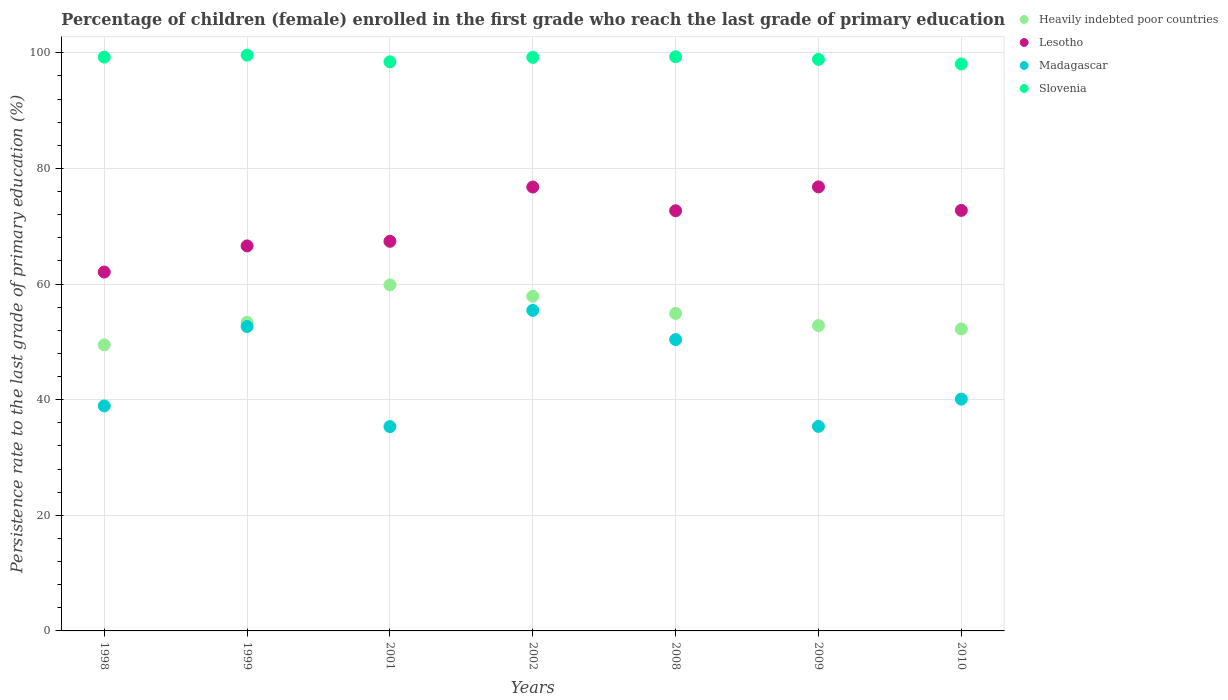How many different coloured dotlines are there?
Your answer should be compact. 4. What is the persistence rate of children in Lesotho in 1999?
Offer a terse response. 66.6. Across all years, what is the maximum persistence rate of children in Heavily indebted poor countries?
Make the answer very short. 59.87. Across all years, what is the minimum persistence rate of children in Lesotho?
Your answer should be compact. 62.08. What is the total persistence rate of children in Madagascar in the graph?
Your answer should be compact. 308.26. What is the difference between the persistence rate of children in Heavily indebted poor countries in 2002 and that in 2010?
Provide a short and direct response. 5.65. What is the difference between the persistence rate of children in Slovenia in 2001 and the persistence rate of children in Heavily indebted poor countries in 2008?
Keep it short and to the point. 43.53. What is the average persistence rate of children in Madagascar per year?
Offer a very short reply. 44.04. In the year 2010, what is the difference between the persistence rate of children in Madagascar and persistence rate of children in Heavily indebted poor countries?
Offer a terse response. -12.14. In how many years, is the persistence rate of children in Madagascar greater than 12 %?
Your answer should be compact. 7. What is the ratio of the persistence rate of children in Lesotho in 1999 to that in 2010?
Make the answer very short. 0.92. Is the persistence rate of children in Madagascar in 1999 less than that in 2010?
Offer a very short reply. No. Is the difference between the persistence rate of children in Madagascar in 1999 and 2010 greater than the difference between the persistence rate of children in Heavily indebted poor countries in 1999 and 2010?
Offer a terse response. Yes. What is the difference between the highest and the second highest persistence rate of children in Slovenia?
Provide a succinct answer. 0.28. What is the difference between the highest and the lowest persistence rate of children in Heavily indebted poor countries?
Provide a succinct answer. 10.38. In how many years, is the persistence rate of children in Heavily indebted poor countries greater than the average persistence rate of children in Heavily indebted poor countries taken over all years?
Provide a short and direct response. 3. Is it the case that in every year, the sum of the persistence rate of children in Lesotho and persistence rate of children in Heavily indebted poor countries  is greater than the sum of persistence rate of children in Slovenia and persistence rate of children in Madagascar?
Provide a succinct answer. Yes. Does the persistence rate of children in Slovenia monotonically increase over the years?
Offer a terse response. No. How many years are there in the graph?
Offer a very short reply. 7. Are the values on the major ticks of Y-axis written in scientific E-notation?
Offer a terse response. No. Does the graph contain any zero values?
Give a very brief answer. No. Where does the legend appear in the graph?
Provide a succinct answer. Top right. How many legend labels are there?
Offer a terse response. 4. What is the title of the graph?
Offer a terse response. Percentage of children (female) enrolled in the first grade who reach the last grade of primary education. Does "Macedonia" appear as one of the legend labels in the graph?
Provide a succinct answer. No. What is the label or title of the X-axis?
Your answer should be very brief. Years. What is the label or title of the Y-axis?
Your answer should be compact. Persistence rate to the last grade of primary education (%). What is the Persistence rate to the last grade of primary education (%) of Heavily indebted poor countries in 1998?
Provide a succinct answer. 49.49. What is the Persistence rate to the last grade of primary education (%) in Lesotho in 1998?
Keep it short and to the point. 62.08. What is the Persistence rate to the last grade of primary education (%) of Madagascar in 1998?
Offer a terse response. 38.92. What is the Persistence rate to the last grade of primary education (%) in Slovenia in 1998?
Keep it short and to the point. 99.26. What is the Persistence rate to the last grade of primary education (%) of Heavily indebted poor countries in 1999?
Provide a succinct answer. 53.38. What is the Persistence rate to the last grade of primary education (%) in Lesotho in 1999?
Ensure brevity in your answer.  66.6. What is the Persistence rate to the last grade of primary education (%) in Madagascar in 1999?
Keep it short and to the point. 52.66. What is the Persistence rate to the last grade of primary education (%) in Slovenia in 1999?
Provide a succinct answer. 99.61. What is the Persistence rate to the last grade of primary education (%) in Heavily indebted poor countries in 2001?
Keep it short and to the point. 59.87. What is the Persistence rate to the last grade of primary education (%) of Lesotho in 2001?
Your answer should be compact. 67.4. What is the Persistence rate to the last grade of primary education (%) in Madagascar in 2001?
Ensure brevity in your answer.  35.35. What is the Persistence rate to the last grade of primary education (%) of Slovenia in 2001?
Offer a very short reply. 98.45. What is the Persistence rate to the last grade of primary education (%) in Heavily indebted poor countries in 2002?
Give a very brief answer. 57.89. What is the Persistence rate to the last grade of primary education (%) in Lesotho in 2002?
Offer a terse response. 76.79. What is the Persistence rate to the last grade of primary education (%) of Madagascar in 2002?
Your answer should be very brief. 55.45. What is the Persistence rate to the last grade of primary education (%) in Slovenia in 2002?
Your response must be concise. 99.23. What is the Persistence rate to the last grade of primary education (%) in Heavily indebted poor countries in 2008?
Your answer should be compact. 54.93. What is the Persistence rate to the last grade of primary education (%) of Lesotho in 2008?
Offer a very short reply. 72.69. What is the Persistence rate to the last grade of primary education (%) of Madagascar in 2008?
Your answer should be very brief. 50.4. What is the Persistence rate to the last grade of primary education (%) in Slovenia in 2008?
Ensure brevity in your answer.  99.32. What is the Persistence rate to the last grade of primary education (%) of Heavily indebted poor countries in 2009?
Keep it short and to the point. 52.82. What is the Persistence rate to the last grade of primary education (%) in Lesotho in 2009?
Make the answer very short. 76.82. What is the Persistence rate to the last grade of primary education (%) in Madagascar in 2009?
Make the answer very short. 35.38. What is the Persistence rate to the last grade of primary education (%) of Slovenia in 2009?
Make the answer very short. 98.88. What is the Persistence rate to the last grade of primary education (%) in Heavily indebted poor countries in 2010?
Offer a terse response. 52.24. What is the Persistence rate to the last grade of primary education (%) in Lesotho in 2010?
Provide a succinct answer. 72.75. What is the Persistence rate to the last grade of primary education (%) in Madagascar in 2010?
Offer a terse response. 40.1. What is the Persistence rate to the last grade of primary education (%) in Slovenia in 2010?
Ensure brevity in your answer.  98.08. Across all years, what is the maximum Persistence rate to the last grade of primary education (%) of Heavily indebted poor countries?
Your response must be concise. 59.87. Across all years, what is the maximum Persistence rate to the last grade of primary education (%) in Lesotho?
Your answer should be very brief. 76.82. Across all years, what is the maximum Persistence rate to the last grade of primary education (%) in Madagascar?
Ensure brevity in your answer.  55.45. Across all years, what is the maximum Persistence rate to the last grade of primary education (%) of Slovenia?
Your response must be concise. 99.61. Across all years, what is the minimum Persistence rate to the last grade of primary education (%) of Heavily indebted poor countries?
Your answer should be compact. 49.49. Across all years, what is the minimum Persistence rate to the last grade of primary education (%) in Lesotho?
Your response must be concise. 62.08. Across all years, what is the minimum Persistence rate to the last grade of primary education (%) in Madagascar?
Give a very brief answer. 35.35. Across all years, what is the minimum Persistence rate to the last grade of primary education (%) in Slovenia?
Make the answer very short. 98.08. What is the total Persistence rate to the last grade of primary education (%) in Heavily indebted poor countries in the graph?
Your answer should be compact. 380.61. What is the total Persistence rate to the last grade of primary education (%) of Lesotho in the graph?
Ensure brevity in your answer.  495.14. What is the total Persistence rate to the last grade of primary education (%) in Madagascar in the graph?
Your answer should be very brief. 308.26. What is the total Persistence rate to the last grade of primary education (%) in Slovenia in the graph?
Your answer should be very brief. 692.83. What is the difference between the Persistence rate to the last grade of primary education (%) in Heavily indebted poor countries in 1998 and that in 1999?
Make the answer very short. -3.89. What is the difference between the Persistence rate to the last grade of primary education (%) in Lesotho in 1998 and that in 1999?
Provide a short and direct response. -4.52. What is the difference between the Persistence rate to the last grade of primary education (%) of Madagascar in 1998 and that in 1999?
Your response must be concise. -13.74. What is the difference between the Persistence rate to the last grade of primary education (%) in Slovenia in 1998 and that in 1999?
Give a very brief answer. -0.34. What is the difference between the Persistence rate to the last grade of primary education (%) in Heavily indebted poor countries in 1998 and that in 2001?
Ensure brevity in your answer.  -10.38. What is the difference between the Persistence rate to the last grade of primary education (%) of Lesotho in 1998 and that in 2001?
Provide a short and direct response. -5.32. What is the difference between the Persistence rate to the last grade of primary education (%) of Madagascar in 1998 and that in 2001?
Your response must be concise. 3.57. What is the difference between the Persistence rate to the last grade of primary education (%) of Slovenia in 1998 and that in 2001?
Keep it short and to the point. 0.81. What is the difference between the Persistence rate to the last grade of primary education (%) in Heavily indebted poor countries in 1998 and that in 2002?
Offer a very short reply. -8.41. What is the difference between the Persistence rate to the last grade of primary education (%) of Lesotho in 1998 and that in 2002?
Offer a terse response. -14.71. What is the difference between the Persistence rate to the last grade of primary education (%) in Madagascar in 1998 and that in 2002?
Offer a very short reply. -16.53. What is the difference between the Persistence rate to the last grade of primary education (%) in Slovenia in 1998 and that in 2002?
Ensure brevity in your answer.  0.03. What is the difference between the Persistence rate to the last grade of primary education (%) in Heavily indebted poor countries in 1998 and that in 2008?
Make the answer very short. -5.44. What is the difference between the Persistence rate to the last grade of primary education (%) in Lesotho in 1998 and that in 2008?
Provide a short and direct response. -10.6. What is the difference between the Persistence rate to the last grade of primary education (%) in Madagascar in 1998 and that in 2008?
Your answer should be very brief. -11.48. What is the difference between the Persistence rate to the last grade of primary education (%) in Slovenia in 1998 and that in 2008?
Keep it short and to the point. -0.06. What is the difference between the Persistence rate to the last grade of primary education (%) of Heavily indebted poor countries in 1998 and that in 2009?
Provide a short and direct response. -3.33. What is the difference between the Persistence rate to the last grade of primary education (%) of Lesotho in 1998 and that in 2009?
Keep it short and to the point. -14.73. What is the difference between the Persistence rate to the last grade of primary education (%) of Madagascar in 1998 and that in 2009?
Offer a terse response. 3.54. What is the difference between the Persistence rate to the last grade of primary education (%) in Slovenia in 1998 and that in 2009?
Your response must be concise. 0.38. What is the difference between the Persistence rate to the last grade of primary education (%) of Heavily indebted poor countries in 1998 and that in 2010?
Keep it short and to the point. -2.75. What is the difference between the Persistence rate to the last grade of primary education (%) of Lesotho in 1998 and that in 2010?
Give a very brief answer. -10.66. What is the difference between the Persistence rate to the last grade of primary education (%) of Madagascar in 1998 and that in 2010?
Offer a very short reply. -1.18. What is the difference between the Persistence rate to the last grade of primary education (%) of Slovenia in 1998 and that in 2010?
Provide a short and direct response. 1.18. What is the difference between the Persistence rate to the last grade of primary education (%) of Heavily indebted poor countries in 1999 and that in 2001?
Make the answer very short. -6.48. What is the difference between the Persistence rate to the last grade of primary education (%) of Lesotho in 1999 and that in 2001?
Offer a terse response. -0.8. What is the difference between the Persistence rate to the last grade of primary education (%) in Madagascar in 1999 and that in 2001?
Your answer should be very brief. 17.31. What is the difference between the Persistence rate to the last grade of primary education (%) in Slovenia in 1999 and that in 2001?
Your response must be concise. 1.15. What is the difference between the Persistence rate to the last grade of primary education (%) in Heavily indebted poor countries in 1999 and that in 2002?
Your answer should be very brief. -4.51. What is the difference between the Persistence rate to the last grade of primary education (%) in Lesotho in 1999 and that in 2002?
Make the answer very short. -10.19. What is the difference between the Persistence rate to the last grade of primary education (%) in Madagascar in 1999 and that in 2002?
Make the answer very short. -2.79. What is the difference between the Persistence rate to the last grade of primary education (%) of Slovenia in 1999 and that in 2002?
Offer a very short reply. 0.38. What is the difference between the Persistence rate to the last grade of primary education (%) of Heavily indebted poor countries in 1999 and that in 2008?
Your answer should be compact. -1.54. What is the difference between the Persistence rate to the last grade of primary education (%) of Lesotho in 1999 and that in 2008?
Offer a terse response. -6.08. What is the difference between the Persistence rate to the last grade of primary education (%) of Madagascar in 1999 and that in 2008?
Give a very brief answer. 2.26. What is the difference between the Persistence rate to the last grade of primary education (%) in Slovenia in 1999 and that in 2008?
Your answer should be very brief. 0.28. What is the difference between the Persistence rate to the last grade of primary education (%) of Heavily indebted poor countries in 1999 and that in 2009?
Ensure brevity in your answer.  0.56. What is the difference between the Persistence rate to the last grade of primary education (%) in Lesotho in 1999 and that in 2009?
Provide a short and direct response. -10.21. What is the difference between the Persistence rate to the last grade of primary education (%) of Madagascar in 1999 and that in 2009?
Your answer should be very brief. 17.28. What is the difference between the Persistence rate to the last grade of primary education (%) of Slovenia in 1999 and that in 2009?
Your response must be concise. 0.73. What is the difference between the Persistence rate to the last grade of primary education (%) of Heavily indebted poor countries in 1999 and that in 2010?
Your response must be concise. 1.14. What is the difference between the Persistence rate to the last grade of primary education (%) in Lesotho in 1999 and that in 2010?
Give a very brief answer. -6.14. What is the difference between the Persistence rate to the last grade of primary education (%) in Madagascar in 1999 and that in 2010?
Offer a terse response. 12.56. What is the difference between the Persistence rate to the last grade of primary education (%) in Slovenia in 1999 and that in 2010?
Your response must be concise. 1.53. What is the difference between the Persistence rate to the last grade of primary education (%) in Heavily indebted poor countries in 2001 and that in 2002?
Provide a short and direct response. 1.97. What is the difference between the Persistence rate to the last grade of primary education (%) in Lesotho in 2001 and that in 2002?
Offer a terse response. -9.39. What is the difference between the Persistence rate to the last grade of primary education (%) in Madagascar in 2001 and that in 2002?
Offer a terse response. -20.1. What is the difference between the Persistence rate to the last grade of primary education (%) in Slovenia in 2001 and that in 2002?
Offer a terse response. -0.77. What is the difference between the Persistence rate to the last grade of primary education (%) in Heavily indebted poor countries in 2001 and that in 2008?
Provide a short and direct response. 4.94. What is the difference between the Persistence rate to the last grade of primary education (%) of Lesotho in 2001 and that in 2008?
Your answer should be very brief. -5.29. What is the difference between the Persistence rate to the last grade of primary education (%) in Madagascar in 2001 and that in 2008?
Your answer should be very brief. -15.05. What is the difference between the Persistence rate to the last grade of primary education (%) of Slovenia in 2001 and that in 2008?
Make the answer very short. -0.87. What is the difference between the Persistence rate to the last grade of primary education (%) of Heavily indebted poor countries in 2001 and that in 2009?
Your answer should be very brief. 7.05. What is the difference between the Persistence rate to the last grade of primary education (%) in Lesotho in 2001 and that in 2009?
Ensure brevity in your answer.  -9.41. What is the difference between the Persistence rate to the last grade of primary education (%) in Madagascar in 2001 and that in 2009?
Keep it short and to the point. -0.03. What is the difference between the Persistence rate to the last grade of primary education (%) of Slovenia in 2001 and that in 2009?
Offer a very short reply. -0.43. What is the difference between the Persistence rate to the last grade of primary education (%) of Heavily indebted poor countries in 2001 and that in 2010?
Provide a succinct answer. 7.63. What is the difference between the Persistence rate to the last grade of primary education (%) in Lesotho in 2001 and that in 2010?
Provide a short and direct response. -5.34. What is the difference between the Persistence rate to the last grade of primary education (%) in Madagascar in 2001 and that in 2010?
Your answer should be compact. -4.75. What is the difference between the Persistence rate to the last grade of primary education (%) in Slovenia in 2001 and that in 2010?
Offer a very short reply. 0.37. What is the difference between the Persistence rate to the last grade of primary education (%) in Heavily indebted poor countries in 2002 and that in 2008?
Your answer should be compact. 2.97. What is the difference between the Persistence rate to the last grade of primary education (%) in Lesotho in 2002 and that in 2008?
Provide a succinct answer. 4.11. What is the difference between the Persistence rate to the last grade of primary education (%) of Madagascar in 2002 and that in 2008?
Your response must be concise. 5.05. What is the difference between the Persistence rate to the last grade of primary education (%) in Slovenia in 2002 and that in 2008?
Your answer should be compact. -0.1. What is the difference between the Persistence rate to the last grade of primary education (%) in Heavily indebted poor countries in 2002 and that in 2009?
Provide a succinct answer. 5.08. What is the difference between the Persistence rate to the last grade of primary education (%) of Lesotho in 2002 and that in 2009?
Keep it short and to the point. -0.02. What is the difference between the Persistence rate to the last grade of primary education (%) of Madagascar in 2002 and that in 2009?
Keep it short and to the point. 20.07. What is the difference between the Persistence rate to the last grade of primary education (%) of Slovenia in 2002 and that in 2009?
Your answer should be compact. 0.35. What is the difference between the Persistence rate to the last grade of primary education (%) in Heavily indebted poor countries in 2002 and that in 2010?
Provide a succinct answer. 5.65. What is the difference between the Persistence rate to the last grade of primary education (%) of Lesotho in 2002 and that in 2010?
Provide a succinct answer. 4.05. What is the difference between the Persistence rate to the last grade of primary education (%) of Madagascar in 2002 and that in 2010?
Offer a very short reply. 15.35. What is the difference between the Persistence rate to the last grade of primary education (%) in Slovenia in 2002 and that in 2010?
Give a very brief answer. 1.15. What is the difference between the Persistence rate to the last grade of primary education (%) in Heavily indebted poor countries in 2008 and that in 2009?
Ensure brevity in your answer.  2.11. What is the difference between the Persistence rate to the last grade of primary education (%) of Lesotho in 2008 and that in 2009?
Provide a short and direct response. -4.13. What is the difference between the Persistence rate to the last grade of primary education (%) of Madagascar in 2008 and that in 2009?
Make the answer very short. 15.02. What is the difference between the Persistence rate to the last grade of primary education (%) in Slovenia in 2008 and that in 2009?
Your response must be concise. 0.45. What is the difference between the Persistence rate to the last grade of primary education (%) of Heavily indebted poor countries in 2008 and that in 2010?
Keep it short and to the point. 2.69. What is the difference between the Persistence rate to the last grade of primary education (%) in Lesotho in 2008 and that in 2010?
Offer a very short reply. -0.06. What is the difference between the Persistence rate to the last grade of primary education (%) in Madagascar in 2008 and that in 2010?
Your response must be concise. 10.3. What is the difference between the Persistence rate to the last grade of primary education (%) in Slovenia in 2008 and that in 2010?
Offer a terse response. 1.25. What is the difference between the Persistence rate to the last grade of primary education (%) in Heavily indebted poor countries in 2009 and that in 2010?
Ensure brevity in your answer.  0.58. What is the difference between the Persistence rate to the last grade of primary education (%) of Lesotho in 2009 and that in 2010?
Offer a terse response. 4.07. What is the difference between the Persistence rate to the last grade of primary education (%) of Madagascar in 2009 and that in 2010?
Give a very brief answer. -4.72. What is the difference between the Persistence rate to the last grade of primary education (%) of Slovenia in 2009 and that in 2010?
Provide a succinct answer. 0.8. What is the difference between the Persistence rate to the last grade of primary education (%) in Heavily indebted poor countries in 1998 and the Persistence rate to the last grade of primary education (%) in Lesotho in 1999?
Give a very brief answer. -17.12. What is the difference between the Persistence rate to the last grade of primary education (%) in Heavily indebted poor countries in 1998 and the Persistence rate to the last grade of primary education (%) in Madagascar in 1999?
Keep it short and to the point. -3.17. What is the difference between the Persistence rate to the last grade of primary education (%) in Heavily indebted poor countries in 1998 and the Persistence rate to the last grade of primary education (%) in Slovenia in 1999?
Your answer should be compact. -50.12. What is the difference between the Persistence rate to the last grade of primary education (%) in Lesotho in 1998 and the Persistence rate to the last grade of primary education (%) in Madagascar in 1999?
Offer a terse response. 9.42. What is the difference between the Persistence rate to the last grade of primary education (%) of Lesotho in 1998 and the Persistence rate to the last grade of primary education (%) of Slovenia in 1999?
Provide a succinct answer. -37.52. What is the difference between the Persistence rate to the last grade of primary education (%) in Madagascar in 1998 and the Persistence rate to the last grade of primary education (%) in Slovenia in 1999?
Offer a terse response. -60.69. What is the difference between the Persistence rate to the last grade of primary education (%) in Heavily indebted poor countries in 1998 and the Persistence rate to the last grade of primary education (%) in Lesotho in 2001?
Keep it short and to the point. -17.91. What is the difference between the Persistence rate to the last grade of primary education (%) of Heavily indebted poor countries in 1998 and the Persistence rate to the last grade of primary education (%) of Madagascar in 2001?
Offer a terse response. 14.14. What is the difference between the Persistence rate to the last grade of primary education (%) of Heavily indebted poor countries in 1998 and the Persistence rate to the last grade of primary education (%) of Slovenia in 2001?
Provide a short and direct response. -48.97. What is the difference between the Persistence rate to the last grade of primary education (%) of Lesotho in 1998 and the Persistence rate to the last grade of primary education (%) of Madagascar in 2001?
Your answer should be very brief. 26.74. What is the difference between the Persistence rate to the last grade of primary education (%) of Lesotho in 1998 and the Persistence rate to the last grade of primary education (%) of Slovenia in 2001?
Your response must be concise. -36.37. What is the difference between the Persistence rate to the last grade of primary education (%) of Madagascar in 1998 and the Persistence rate to the last grade of primary education (%) of Slovenia in 2001?
Provide a short and direct response. -59.53. What is the difference between the Persistence rate to the last grade of primary education (%) in Heavily indebted poor countries in 1998 and the Persistence rate to the last grade of primary education (%) in Lesotho in 2002?
Your answer should be very brief. -27.31. What is the difference between the Persistence rate to the last grade of primary education (%) in Heavily indebted poor countries in 1998 and the Persistence rate to the last grade of primary education (%) in Madagascar in 2002?
Provide a short and direct response. -5.96. What is the difference between the Persistence rate to the last grade of primary education (%) in Heavily indebted poor countries in 1998 and the Persistence rate to the last grade of primary education (%) in Slovenia in 2002?
Your answer should be very brief. -49.74. What is the difference between the Persistence rate to the last grade of primary education (%) of Lesotho in 1998 and the Persistence rate to the last grade of primary education (%) of Madagascar in 2002?
Provide a succinct answer. 6.64. What is the difference between the Persistence rate to the last grade of primary education (%) in Lesotho in 1998 and the Persistence rate to the last grade of primary education (%) in Slovenia in 2002?
Your response must be concise. -37.14. What is the difference between the Persistence rate to the last grade of primary education (%) in Madagascar in 1998 and the Persistence rate to the last grade of primary education (%) in Slovenia in 2002?
Offer a very short reply. -60.31. What is the difference between the Persistence rate to the last grade of primary education (%) in Heavily indebted poor countries in 1998 and the Persistence rate to the last grade of primary education (%) in Lesotho in 2008?
Your answer should be compact. -23.2. What is the difference between the Persistence rate to the last grade of primary education (%) in Heavily indebted poor countries in 1998 and the Persistence rate to the last grade of primary education (%) in Madagascar in 2008?
Keep it short and to the point. -0.91. What is the difference between the Persistence rate to the last grade of primary education (%) of Heavily indebted poor countries in 1998 and the Persistence rate to the last grade of primary education (%) of Slovenia in 2008?
Give a very brief answer. -49.84. What is the difference between the Persistence rate to the last grade of primary education (%) in Lesotho in 1998 and the Persistence rate to the last grade of primary education (%) in Madagascar in 2008?
Offer a terse response. 11.68. What is the difference between the Persistence rate to the last grade of primary education (%) of Lesotho in 1998 and the Persistence rate to the last grade of primary education (%) of Slovenia in 2008?
Offer a very short reply. -37.24. What is the difference between the Persistence rate to the last grade of primary education (%) in Madagascar in 1998 and the Persistence rate to the last grade of primary education (%) in Slovenia in 2008?
Provide a succinct answer. -60.4. What is the difference between the Persistence rate to the last grade of primary education (%) of Heavily indebted poor countries in 1998 and the Persistence rate to the last grade of primary education (%) of Lesotho in 2009?
Offer a very short reply. -27.33. What is the difference between the Persistence rate to the last grade of primary education (%) in Heavily indebted poor countries in 1998 and the Persistence rate to the last grade of primary education (%) in Madagascar in 2009?
Ensure brevity in your answer.  14.11. What is the difference between the Persistence rate to the last grade of primary education (%) in Heavily indebted poor countries in 1998 and the Persistence rate to the last grade of primary education (%) in Slovenia in 2009?
Make the answer very short. -49.39. What is the difference between the Persistence rate to the last grade of primary education (%) in Lesotho in 1998 and the Persistence rate to the last grade of primary education (%) in Madagascar in 2009?
Provide a succinct answer. 26.71. What is the difference between the Persistence rate to the last grade of primary education (%) of Lesotho in 1998 and the Persistence rate to the last grade of primary education (%) of Slovenia in 2009?
Ensure brevity in your answer.  -36.79. What is the difference between the Persistence rate to the last grade of primary education (%) of Madagascar in 1998 and the Persistence rate to the last grade of primary education (%) of Slovenia in 2009?
Offer a very short reply. -59.96. What is the difference between the Persistence rate to the last grade of primary education (%) of Heavily indebted poor countries in 1998 and the Persistence rate to the last grade of primary education (%) of Lesotho in 2010?
Your response must be concise. -23.26. What is the difference between the Persistence rate to the last grade of primary education (%) of Heavily indebted poor countries in 1998 and the Persistence rate to the last grade of primary education (%) of Madagascar in 2010?
Your answer should be compact. 9.39. What is the difference between the Persistence rate to the last grade of primary education (%) of Heavily indebted poor countries in 1998 and the Persistence rate to the last grade of primary education (%) of Slovenia in 2010?
Offer a very short reply. -48.59. What is the difference between the Persistence rate to the last grade of primary education (%) of Lesotho in 1998 and the Persistence rate to the last grade of primary education (%) of Madagascar in 2010?
Make the answer very short. 21.98. What is the difference between the Persistence rate to the last grade of primary education (%) of Lesotho in 1998 and the Persistence rate to the last grade of primary education (%) of Slovenia in 2010?
Ensure brevity in your answer.  -35.99. What is the difference between the Persistence rate to the last grade of primary education (%) of Madagascar in 1998 and the Persistence rate to the last grade of primary education (%) of Slovenia in 2010?
Provide a succinct answer. -59.16. What is the difference between the Persistence rate to the last grade of primary education (%) in Heavily indebted poor countries in 1999 and the Persistence rate to the last grade of primary education (%) in Lesotho in 2001?
Ensure brevity in your answer.  -14.02. What is the difference between the Persistence rate to the last grade of primary education (%) of Heavily indebted poor countries in 1999 and the Persistence rate to the last grade of primary education (%) of Madagascar in 2001?
Give a very brief answer. 18.03. What is the difference between the Persistence rate to the last grade of primary education (%) of Heavily indebted poor countries in 1999 and the Persistence rate to the last grade of primary education (%) of Slovenia in 2001?
Your answer should be very brief. -45.07. What is the difference between the Persistence rate to the last grade of primary education (%) in Lesotho in 1999 and the Persistence rate to the last grade of primary education (%) in Madagascar in 2001?
Keep it short and to the point. 31.25. What is the difference between the Persistence rate to the last grade of primary education (%) in Lesotho in 1999 and the Persistence rate to the last grade of primary education (%) in Slovenia in 2001?
Offer a very short reply. -31.85. What is the difference between the Persistence rate to the last grade of primary education (%) of Madagascar in 1999 and the Persistence rate to the last grade of primary education (%) of Slovenia in 2001?
Offer a terse response. -45.79. What is the difference between the Persistence rate to the last grade of primary education (%) in Heavily indebted poor countries in 1999 and the Persistence rate to the last grade of primary education (%) in Lesotho in 2002?
Keep it short and to the point. -23.41. What is the difference between the Persistence rate to the last grade of primary education (%) of Heavily indebted poor countries in 1999 and the Persistence rate to the last grade of primary education (%) of Madagascar in 2002?
Ensure brevity in your answer.  -2.07. What is the difference between the Persistence rate to the last grade of primary education (%) of Heavily indebted poor countries in 1999 and the Persistence rate to the last grade of primary education (%) of Slovenia in 2002?
Your response must be concise. -45.85. What is the difference between the Persistence rate to the last grade of primary education (%) of Lesotho in 1999 and the Persistence rate to the last grade of primary education (%) of Madagascar in 2002?
Offer a very short reply. 11.16. What is the difference between the Persistence rate to the last grade of primary education (%) in Lesotho in 1999 and the Persistence rate to the last grade of primary education (%) in Slovenia in 2002?
Keep it short and to the point. -32.62. What is the difference between the Persistence rate to the last grade of primary education (%) in Madagascar in 1999 and the Persistence rate to the last grade of primary education (%) in Slovenia in 2002?
Provide a short and direct response. -46.57. What is the difference between the Persistence rate to the last grade of primary education (%) of Heavily indebted poor countries in 1999 and the Persistence rate to the last grade of primary education (%) of Lesotho in 2008?
Provide a short and direct response. -19.31. What is the difference between the Persistence rate to the last grade of primary education (%) in Heavily indebted poor countries in 1999 and the Persistence rate to the last grade of primary education (%) in Madagascar in 2008?
Offer a terse response. 2.98. What is the difference between the Persistence rate to the last grade of primary education (%) of Heavily indebted poor countries in 1999 and the Persistence rate to the last grade of primary education (%) of Slovenia in 2008?
Your answer should be very brief. -45.94. What is the difference between the Persistence rate to the last grade of primary education (%) in Lesotho in 1999 and the Persistence rate to the last grade of primary education (%) in Madagascar in 2008?
Keep it short and to the point. 16.2. What is the difference between the Persistence rate to the last grade of primary education (%) of Lesotho in 1999 and the Persistence rate to the last grade of primary education (%) of Slovenia in 2008?
Offer a very short reply. -32.72. What is the difference between the Persistence rate to the last grade of primary education (%) in Madagascar in 1999 and the Persistence rate to the last grade of primary education (%) in Slovenia in 2008?
Ensure brevity in your answer.  -46.66. What is the difference between the Persistence rate to the last grade of primary education (%) in Heavily indebted poor countries in 1999 and the Persistence rate to the last grade of primary education (%) in Lesotho in 2009?
Keep it short and to the point. -23.43. What is the difference between the Persistence rate to the last grade of primary education (%) in Heavily indebted poor countries in 1999 and the Persistence rate to the last grade of primary education (%) in Madagascar in 2009?
Your answer should be compact. 18. What is the difference between the Persistence rate to the last grade of primary education (%) of Heavily indebted poor countries in 1999 and the Persistence rate to the last grade of primary education (%) of Slovenia in 2009?
Make the answer very short. -45.5. What is the difference between the Persistence rate to the last grade of primary education (%) of Lesotho in 1999 and the Persistence rate to the last grade of primary education (%) of Madagascar in 2009?
Make the answer very short. 31.22. What is the difference between the Persistence rate to the last grade of primary education (%) in Lesotho in 1999 and the Persistence rate to the last grade of primary education (%) in Slovenia in 2009?
Provide a succinct answer. -32.27. What is the difference between the Persistence rate to the last grade of primary education (%) in Madagascar in 1999 and the Persistence rate to the last grade of primary education (%) in Slovenia in 2009?
Offer a terse response. -46.22. What is the difference between the Persistence rate to the last grade of primary education (%) in Heavily indebted poor countries in 1999 and the Persistence rate to the last grade of primary education (%) in Lesotho in 2010?
Offer a terse response. -19.36. What is the difference between the Persistence rate to the last grade of primary education (%) of Heavily indebted poor countries in 1999 and the Persistence rate to the last grade of primary education (%) of Madagascar in 2010?
Give a very brief answer. 13.28. What is the difference between the Persistence rate to the last grade of primary education (%) in Heavily indebted poor countries in 1999 and the Persistence rate to the last grade of primary education (%) in Slovenia in 2010?
Offer a terse response. -44.7. What is the difference between the Persistence rate to the last grade of primary education (%) of Lesotho in 1999 and the Persistence rate to the last grade of primary education (%) of Madagascar in 2010?
Your answer should be compact. 26.5. What is the difference between the Persistence rate to the last grade of primary education (%) of Lesotho in 1999 and the Persistence rate to the last grade of primary education (%) of Slovenia in 2010?
Provide a succinct answer. -31.47. What is the difference between the Persistence rate to the last grade of primary education (%) of Madagascar in 1999 and the Persistence rate to the last grade of primary education (%) of Slovenia in 2010?
Give a very brief answer. -45.42. What is the difference between the Persistence rate to the last grade of primary education (%) in Heavily indebted poor countries in 2001 and the Persistence rate to the last grade of primary education (%) in Lesotho in 2002?
Keep it short and to the point. -16.93. What is the difference between the Persistence rate to the last grade of primary education (%) of Heavily indebted poor countries in 2001 and the Persistence rate to the last grade of primary education (%) of Madagascar in 2002?
Ensure brevity in your answer.  4.42. What is the difference between the Persistence rate to the last grade of primary education (%) in Heavily indebted poor countries in 2001 and the Persistence rate to the last grade of primary education (%) in Slovenia in 2002?
Your answer should be very brief. -39.36. What is the difference between the Persistence rate to the last grade of primary education (%) of Lesotho in 2001 and the Persistence rate to the last grade of primary education (%) of Madagascar in 2002?
Offer a terse response. 11.95. What is the difference between the Persistence rate to the last grade of primary education (%) in Lesotho in 2001 and the Persistence rate to the last grade of primary education (%) in Slovenia in 2002?
Give a very brief answer. -31.83. What is the difference between the Persistence rate to the last grade of primary education (%) of Madagascar in 2001 and the Persistence rate to the last grade of primary education (%) of Slovenia in 2002?
Give a very brief answer. -63.88. What is the difference between the Persistence rate to the last grade of primary education (%) of Heavily indebted poor countries in 2001 and the Persistence rate to the last grade of primary education (%) of Lesotho in 2008?
Provide a succinct answer. -12.82. What is the difference between the Persistence rate to the last grade of primary education (%) in Heavily indebted poor countries in 2001 and the Persistence rate to the last grade of primary education (%) in Madagascar in 2008?
Offer a very short reply. 9.47. What is the difference between the Persistence rate to the last grade of primary education (%) of Heavily indebted poor countries in 2001 and the Persistence rate to the last grade of primary education (%) of Slovenia in 2008?
Make the answer very short. -39.46. What is the difference between the Persistence rate to the last grade of primary education (%) of Lesotho in 2001 and the Persistence rate to the last grade of primary education (%) of Madagascar in 2008?
Provide a short and direct response. 17. What is the difference between the Persistence rate to the last grade of primary education (%) in Lesotho in 2001 and the Persistence rate to the last grade of primary education (%) in Slovenia in 2008?
Your answer should be very brief. -31.92. What is the difference between the Persistence rate to the last grade of primary education (%) in Madagascar in 2001 and the Persistence rate to the last grade of primary education (%) in Slovenia in 2008?
Make the answer very short. -63.98. What is the difference between the Persistence rate to the last grade of primary education (%) of Heavily indebted poor countries in 2001 and the Persistence rate to the last grade of primary education (%) of Lesotho in 2009?
Your response must be concise. -16.95. What is the difference between the Persistence rate to the last grade of primary education (%) in Heavily indebted poor countries in 2001 and the Persistence rate to the last grade of primary education (%) in Madagascar in 2009?
Provide a succinct answer. 24.49. What is the difference between the Persistence rate to the last grade of primary education (%) in Heavily indebted poor countries in 2001 and the Persistence rate to the last grade of primary education (%) in Slovenia in 2009?
Your response must be concise. -39.01. What is the difference between the Persistence rate to the last grade of primary education (%) of Lesotho in 2001 and the Persistence rate to the last grade of primary education (%) of Madagascar in 2009?
Your answer should be compact. 32.02. What is the difference between the Persistence rate to the last grade of primary education (%) of Lesotho in 2001 and the Persistence rate to the last grade of primary education (%) of Slovenia in 2009?
Make the answer very short. -31.48. What is the difference between the Persistence rate to the last grade of primary education (%) in Madagascar in 2001 and the Persistence rate to the last grade of primary education (%) in Slovenia in 2009?
Keep it short and to the point. -63.53. What is the difference between the Persistence rate to the last grade of primary education (%) in Heavily indebted poor countries in 2001 and the Persistence rate to the last grade of primary education (%) in Lesotho in 2010?
Offer a terse response. -12.88. What is the difference between the Persistence rate to the last grade of primary education (%) in Heavily indebted poor countries in 2001 and the Persistence rate to the last grade of primary education (%) in Madagascar in 2010?
Provide a short and direct response. 19.77. What is the difference between the Persistence rate to the last grade of primary education (%) of Heavily indebted poor countries in 2001 and the Persistence rate to the last grade of primary education (%) of Slovenia in 2010?
Ensure brevity in your answer.  -38.21. What is the difference between the Persistence rate to the last grade of primary education (%) in Lesotho in 2001 and the Persistence rate to the last grade of primary education (%) in Madagascar in 2010?
Offer a very short reply. 27.3. What is the difference between the Persistence rate to the last grade of primary education (%) in Lesotho in 2001 and the Persistence rate to the last grade of primary education (%) in Slovenia in 2010?
Your response must be concise. -30.68. What is the difference between the Persistence rate to the last grade of primary education (%) in Madagascar in 2001 and the Persistence rate to the last grade of primary education (%) in Slovenia in 2010?
Your response must be concise. -62.73. What is the difference between the Persistence rate to the last grade of primary education (%) in Heavily indebted poor countries in 2002 and the Persistence rate to the last grade of primary education (%) in Lesotho in 2008?
Keep it short and to the point. -14.79. What is the difference between the Persistence rate to the last grade of primary education (%) of Heavily indebted poor countries in 2002 and the Persistence rate to the last grade of primary education (%) of Madagascar in 2008?
Offer a terse response. 7.49. What is the difference between the Persistence rate to the last grade of primary education (%) in Heavily indebted poor countries in 2002 and the Persistence rate to the last grade of primary education (%) in Slovenia in 2008?
Your answer should be compact. -41.43. What is the difference between the Persistence rate to the last grade of primary education (%) in Lesotho in 2002 and the Persistence rate to the last grade of primary education (%) in Madagascar in 2008?
Give a very brief answer. 26.39. What is the difference between the Persistence rate to the last grade of primary education (%) in Lesotho in 2002 and the Persistence rate to the last grade of primary education (%) in Slovenia in 2008?
Offer a very short reply. -22.53. What is the difference between the Persistence rate to the last grade of primary education (%) in Madagascar in 2002 and the Persistence rate to the last grade of primary education (%) in Slovenia in 2008?
Keep it short and to the point. -43.88. What is the difference between the Persistence rate to the last grade of primary education (%) of Heavily indebted poor countries in 2002 and the Persistence rate to the last grade of primary education (%) of Lesotho in 2009?
Keep it short and to the point. -18.92. What is the difference between the Persistence rate to the last grade of primary education (%) in Heavily indebted poor countries in 2002 and the Persistence rate to the last grade of primary education (%) in Madagascar in 2009?
Offer a very short reply. 22.51. What is the difference between the Persistence rate to the last grade of primary education (%) of Heavily indebted poor countries in 2002 and the Persistence rate to the last grade of primary education (%) of Slovenia in 2009?
Keep it short and to the point. -40.98. What is the difference between the Persistence rate to the last grade of primary education (%) of Lesotho in 2002 and the Persistence rate to the last grade of primary education (%) of Madagascar in 2009?
Give a very brief answer. 41.42. What is the difference between the Persistence rate to the last grade of primary education (%) in Lesotho in 2002 and the Persistence rate to the last grade of primary education (%) in Slovenia in 2009?
Provide a succinct answer. -22.08. What is the difference between the Persistence rate to the last grade of primary education (%) in Madagascar in 2002 and the Persistence rate to the last grade of primary education (%) in Slovenia in 2009?
Your answer should be very brief. -43.43. What is the difference between the Persistence rate to the last grade of primary education (%) in Heavily indebted poor countries in 2002 and the Persistence rate to the last grade of primary education (%) in Lesotho in 2010?
Provide a succinct answer. -14.85. What is the difference between the Persistence rate to the last grade of primary education (%) of Heavily indebted poor countries in 2002 and the Persistence rate to the last grade of primary education (%) of Madagascar in 2010?
Offer a very short reply. 17.79. What is the difference between the Persistence rate to the last grade of primary education (%) of Heavily indebted poor countries in 2002 and the Persistence rate to the last grade of primary education (%) of Slovenia in 2010?
Your response must be concise. -40.18. What is the difference between the Persistence rate to the last grade of primary education (%) in Lesotho in 2002 and the Persistence rate to the last grade of primary education (%) in Madagascar in 2010?
Offer a very short reply. 36.69. What is the difference between the Persistence rate to the last grade of primary education (%) of Lesotho in 2002 and the Persistence rate to the last grade of primary education (%) of Slovenia in 2010?
Make the answer very short. -21.28. What is the difference between the Persistence rate to the last grade of primary education (%) of Madagascar in 2002 and the Persistence rate to the last grade of primary education (%) of Slovenia in 2010?
Your answer should be compact. -42.63. What is the difference between the Persistence rate to the last grade of primary education (%) in Heavily indebted poor countries in 2008 and the Persistence rate to the last grade of primary education (%) in Lesotho in 2009?
Keep it short and to the point. -21.89. What is the difference between the Persistence rate to the last grade of primary education (%) of Heavily indebted poor countries in 2008 and the Persistence rate to the last grade of primary education (%) of Madagascar in 2009?
Offer a very short reply. 19.55. What is the difference between the Persistence rate to the last grade of primary education (%) of Heavily indebted poor countries in 2008 and the Persistence rate to the last grade of primary education (%) of Slovenia in 2009?
Provide a short and direct response. -43.95. What is the difference between the Persistence rate to the last grade of primary education (%) in Lesotho in 2008 and the Persistence rate to the last grade of primary education (%) in Madagascar in 2009?
Your response must be concise. 37.31. What is the difference between the Persistence rate to the last grade of primary education (%) in Lesotho in 2008 and the Persistence rate to the last grade of primary education (%) in Slovenia in 2009?
Your answer should be very brief. -26.19. What is the difference between the Persistence rate to the last grade of primary education (%) in Madagascar in 2008 and the Persistence rate to the last grade of primary education (%) in Slovenia in 2009?
Your response must be concise. -48.48. What is the difference between the Persistence rate to the last grade of primary education (%) of Heavily indebted poor countries in 2008 and the Persistence rate to the last grade of primary education (%) of Lesotho in 2010?
Ensure brevity in your answer.  -17.82. What is the difference between the Persistence rate to the last grade of primary education (%) in Heavily indebted poor countries in 2008 and the Persistence rate to the last grade of primary education (%) in Madagascar in 2010?
Ensure brevity in your answer.  14.83. What is the difference between the Persistence rate to the last grade of primary education (%) in Heavily indebted poor countries in 2008 and the Persistence rate to the last grade of primary education (%) in Slovenia in 2010?
Your answer should be very brief. -43.15. What is the difference between the Persistence rate to the last grade of primary education (%) in Lesotho in 2008 and the Persistence rate to the last grade of primary education (%) in Madagascar in 2010?
Your answer should be very brief. 32.59. What is the difference between the Persistence rate to the last grade of primary education (%) in Lesotho in 2008 and the Persistence rate to the last grade of primary education (%) in Slovenia in 2010?
Your answer should be very brief. -25.39. What is the difference between the Persistence rate to the last grade of primary education (%) in Madagascar in 2008 and the Persistence rate to the last grade of primary education (%) in Slovenia in 2010?
Ensure brevity in your answer.  -47.68. What is the difference between the Persistence rate to the last grade of primary education (%) in Heavily indebted poor countries in 2009 and the Persistence rate to the last grade of primary education (%) in Lesotho in 2010?
Your answer should be very brief. -19.93. What is the difference between the Persistence rate to the last grade of primary education (%) of Heavily indebted poor countries in 2009 and the Persistence rate to the last grade of primary education (%) of Madagascar in 2010?
Your answer should be compact. 12.72. What is the difference between the Persistence rate to the last grade of primary education (%) in Heavily indebted poor countries in 2009 and the Persistence rate to the last grade of primary education (%) in Slovenia in 2010?
Your answer should be very brief. -45.26. What is the difference between the Persistence rate to the last grade of primary education (%) of Lesotho in 2009 and the Persistence rate to the last grade of primary education (%) of Madagascar in 2010?
Your answer should be compact. 36.72. What is the difference between the Persistence rate to the last grade of primary education (%) of Lesotho in 2009 and the Persistence rate to the last grade of primary education (%) of Slovenia in 2010?
Provide a succinct answer. -21.26. What is the difference between the Persistence rate to the last grade of primary education (%) of Madagascar in 2009 and the Persistence rate to the last grade of primary education (%) of Slovenia in 2010?
Keep it short and to the point. -62.7. What is the average Persistence rate to the last grade of primary education (%) in Heavily indebted poor countries per year?
Your response must be concise. 54.37. What is the average Persistence rate to the last grade of primary education (%) of Lesotho per year?
Your answer should be compact. 70.73. What is the average Persistence rate to the last grade of primary education (%) of Madagascar per year?
Offer a terse response. 44.04. What is the average Persistence rate to the last grade of primary education (%) of Slovenia per year?
Keep it short and to the point. 98.98. In the year 1998, what is the difference between the Persistence rate to the last grade of primary education (%) of Heavily indebted poor countries and Persistence rate to the last grade of primary education (%) of Lesotho?
Ensure brevity in your answer.  -12.6. In the year 1998, what is the difference between the Persistence rate to the last grade of primary education (%) of Heavily indebted poor countries and Persistence rate to the last grade of primary education (%) of Madagascar?
Offer a very short reply. 10.57. In the year 1998, what is the difference between the Persistence rate to the last grade of primary education (%) of Heavily indebted poor countries and Persistence rate to the last grade of primary education (%) of Slovenia?
Offer a very short reply. -49.77. In the year 1998, what is the difference between the Persistence rate to the last grade of primary education (%) in Lesotho and Persistence rate to the last grade of primary education (%) in Madagascar?
Provide a succinct answer. 23.16. In the year 1998, what is the difference between the Persistence rate to the last grade of primary education (%) in Lesotho and Persistence rate to the last grade of primary education (%) in Slovenia?
Offer a very short reply. -37.18. In the year 1998, what is the difference between the Persistence rate to the last grade of primary education (%) of Madagascar and Persistence rate to the last grade of primary education (%) of Slovenia?
Your response must be concise. -60.34. In the year 1999, what is the difference between the Persistence rate to the last grade of primary education (%) of Heavily indebted poor countries and Persistence rate to the last grade of primary education (%) of Lesotho?
Give a very brief answer. -13.22. In the year 1999, what is the difference between the Persistence rate to the last grade of primary education (%) of Heavily indebted poor countries and Persistence rate to the last grade of primary education (%) of Madagascar?
Your response must be concise. 0.72. In the year 1999, what is the difference between the Persistence rate to the last grade of primary education (%) of Heavily indebted poor countries and Persistence rate to the last grade of primary education (%) of Slovenia?
Make the answer very short. -46.22. In the year 1999, what is the difference between the Persistence rate to the last grade of primary education (%) in Lesotho and Persistence rate to the last grade of primary education (%) in Madagascar?
Offer a very short reply. 13.94. In the year 1999, what is the difference between the Persistence rate to the last grade of primary education (%) of Lesotho and Persistence rate to the last grade of primary education (%) of Slovenia?
Provide a succinct answer. -33. In the year 1999, what is the difference between the Persistence rate to the last grade of primary education (%) of Madagascar and Persistence rate to the last grade of primary education (%) of Slovenia?
Your answer should be very brief. -46.95. In the year 2001, what is the difference between the Persistence rate to the last grade of primary education (%) in Heavily indebted poor countries and Persistence rate to the last grade of primary education (%) in Lesotho?
Your response must be concise. -7.54. In the year 2001, what is the difference between the Persistence rate to the last grade of primary education (%) of Heavily indebted poor countries and Persistence rate to the last grade of primary education (%) of Madagascar?
Keep it short and to the point. 24.52. In the year 2001, what is the difference between the Persistence rate to the last grade of primary education (%) in Heavily indebted poor countries and Persistence rate to the last grade of primary education (%) in Slovenia?
Your response must be concise. -38.59. In the year 2001, what is the difference between the Persistence rate to the last grade of primary education (%) of Lesotho and Persistence rate to the last grade of primary education (%) of Madagascar?
Give a very brief answer. 32.05. In the year 2001, what is the difference between the Persistence rate to the last grade of primary education (%) in Lesotho and Persistence rate to the last grade of primary education (%) in Slovenia?
Make the answer very short. -31.05. In the year 2001, what is the difference between the Persistence rate to the last grade of primary education (%) of Madagascar and Persistence rate to the last grade of primary education (%) of Slovenia?
Offer a very short reply. -63.1. In the year 2002, what is the difference between the Persistence rate to the last grade of primary education (%) of Heavily indebted poor countries and Persistence rate to the last grade of primary education (%) of Lesotho?
Offer a very short reply. -18.9. In the year 2002, what is the difference between the Persistence rate to the last grade of primary education (%) in Heavily indebted poor countries and Persistence rate to the last grade of primary education (%) in Madagascar?
Your response must be concise. 2.45. In the year 2002, what is the difference between the Persistence rate to the last grade of primary education (%) in Heavily indebted poor countries and Persistence rate to the last grade of primary education (%) in Slovenia?
Your response must be concise. -41.33. In the year 2002, what is the difference between the Persistence rate to the last grade of primary education (%) of Lesotho and Persistence rate to the last grade of primary education (%) of Madagascar?
Offer a terse response. 21.35. In the year 2002, what is the difference between the Persistence rate to the last grade of primary education (%) of Lesotho and Persistence rate to the last grade of primary education (%) of Slovenia?
Give a very brief answer. -22.43. In the year 2002, what is the difference between the Persistence rate to the last grade of primary education (%) in Madagascar and Persistence rate to the last grade of primary education (%) in Slovenia?
Give a very brief answer. -43.78. In the year 2008, what is the difference between the Persistence rate to the last grade of primary education (%) of Heavily indebted poor countries and Persistence rate to the last grade of primary education (%) of Lesotho?
Your answer should be very brief. -17.76. In the year 2008, what is the difference between the Persistence rate to the last grade of primary education (%) in Heavily indebted poor countries and Persistence rate to the last grade of primary education (%) in Madagascar?
Your response must be concise. 4.53. In the year 2008, what is the difference between the Persistence rate to the last grade of primary education (%) of Heavily indebted poor countries and Persistence rate to the last grade of primary education (%) of Slovenia?
Offer a very short reply. -44.4. In the year 2008, what is the difference between the Persistence rate to the last grade of primary education (%) in Lesotho and Persistence rate to the last grade of primary education (%) in Madagascar?
Your answer should be very brief. 22.29. In the year 2008, what is the difference between the Persistence rate to the last grade of primary education (%) in Lesotho and Persistence rate to the last grade of primary education (%) in Slovenia?
Your answer should be compact. -26.64. In the year 2008, what is the difference between the Persistence rate to the last grade of primary education (%) of Madagascar and Persistence rate to the last grade of primary education (%) of Slovenia?
Make the answer very short. -48.92. In the year 2009, what is the difference between the Persistence rate to the last grade of primary education (%) in Heavily indebted poor countries and Persistence rate to the last grade of primary education (%) in Lesotho?
Ensure brevity in your answer.  -24. In the year 2009, what is the difference between the Persistence rate to the last grade of primary education (%) of Heavily indebted poor countries and Persistence rate to the last grade of primary education (%) of Madagascar?
Give a very brief answer. 17.44. In the year 2009, what is the difference between the Persistence rate to the last grade of primary education (%) in Heavily indebted poor countries and Persistence rate to the last grade of primary education (%) in Slovenia?
Give a very brief answer. -46.06. In the year 2009, what is the difference between the Persistence rate to the last grade of primary education (%) of Lesotho and Persistence rate to the last grade of primary education (%) of Madagascar?
Keep it short and to the point. 41.44. In the year 2009, what is the difference between the Persistence rate to the last grade of primary education (%) in Lesotho and Persistence rate to the last grade of primary education (%) in Slovenia?
Provide a short and direct response. -22.06. In the year 2009, what is the difference between the Persistence rate to the last grade of primary education (%) in Madagascar and Persistence rate to the last grade of primary education (%) in Slovenia?
Your answer should be very brief. -63.5. In the year 2010, what is the difference between the Persistence rate to the last grade of primary education (%) in Heavily indebted poor countries and Persistence rate to the last grade of primary education (%) in Lesotho?
Your response must be concise. -20.51. In the year 2010, what is the difference between the Persistence rate to the last grade of primary education (%) in Heavily indebted poor countries and Persistence rate to the last grade of primary education (%) in Madagascar?
Your response must be concise. 12.14. In the year 2010, what is the difference between the Persistence rate to the last grade of primary education (%) of Heavily indebted poor countries and Persistence rate to the last grade of primary education (%) of Slovenia?
Ensure brevity in your answer.  -45.84. In the year 2010, what is the difference between the Persistence rate to the last grade of primary education (%) of Lesotho and Persistence rate to the last grade of primary education (%) of Madagascar?
Your answer should be very brief. 32.65. In the year 2010, what is the difference between the Persistence rate to the last grade of primary education (%) of Lesotho and Persistence rate to the last grade of primary education (%) of Slovenia?
Provide a succinct answer. -25.33. In the year 2010, what is the difference between the Persistence rate to the last grade of primary education (%) of Madagascar and Persistence rate to the last grade of primary education (%) of Slovenia?
Ensure brevity in your answer.  -57.98. What is the ratio of the Persistence rate to the last grade of primary education (%) in Heavily indebted poor countries in 1998 to that in 1999?
Your response must be concise. 0.93. What is the ratio of the Persistence rate to the last grade of primary education (%) in Lesotho in 1998 to that in 1999?
Your answer should be compact. 0.93. What is the ratio of the Persistence rate to the last grade of primary education (%) in Madagascar in 1998 to that in 1999?
Your response must be concise. 0.74. What is the ratio of the Persistence rate to the last grade of primary education (%) of Slovenia in 1998 to that in 1999?
Give a very brief answer. 1. What is the ratio of the Persistence rate to the last grade of primary education (%) in Heavily indebted poor countries in 1998 to that in 2001?
Ensure brevity in your answer.  0.83. What is the ratio of the Persistence rate to the last grade of primary education (%) in Lesotho in 1998 to that in 2001?
Give a very brief answer. 0.92. What is the ratio of the Persistence rate to the last grade of primary education (%) in Madagascar in 1998 to that in 2001?
Offer a very short reply. 1.1. What is the ratio of the Persistence rate to the last grade of primary education (%) in Slovenia in 1998 to that in 2001?
Give a very brief answer. 1.01. What is the ratio of the Persistence rate to the last grade of primary education (%) of Heavily indebted poor countries in 1998 to that in 2002?
Provide a short and direct response. 0.85. What is the ratio of the Persistence rate to the last grade of primary education (%) in Lesotho in 1998 to that in 2002?
Give a very brief answer. 0.81. What is the ratio of the Persistence rate to the last grade of primary education (%) in Madagascar in 1998 to that in 2002?
Your answer should be compact. 0.7. What is the ratio of the Persistence rate to the last grade of primary education (%) of Heavily indebted poor countries in 1998 to that in 2008?
Your answer should be very brief. 0.9. What is the ratio of the Persistence rate to the last grade of primary education (%) of Lesotho in 1998 to that in 2008?
Offer a terse response. 0.85. What is the ratio of the Persistence rate to the last grade of primary education (%) in Madagascar in 1998 to that in 2008?
Your answer should be compact. 0.77. What is the ratio of the Persistence rate to the last grade of primary education (%) in Slovenia in 1998 to that in 2008?
Provide a short and direct response. 1. What is the ratio of the Persistence rate to the last grade of primary education (%) of Heavily indebted poor countries in 1998 to that in 2009?
Provide a short and direct response. 0.94. What is the ratio of the Persistence rate to the last grade of primary education (%) of Lesotho in 1998 to that in 2009?
Make the answer very short. 0.81. What is the ratio of the Persistence rate to the last grade of primary education (%) of Madagascar in 1998 to that in 2009?
Make the answer very short. 1.1. What is the ratio of the Persistence rate to the last grade of primary education (%) of Slovenia in 1998 to that in 2009?
Keep it short and to the point. 1. What is the ratio of the Persistence rate to the last grade of primary education (%) in Heavily indebted poor countries in 1998 to that in 2010?
Your response must be concise. 0.95. What is the ratio of the Persistence rate to the last grade of primary education (%) in Lesotho in 1998 to that in 2010?
Provide a succinct answer. 0.85. What is the ratio of the Persistence rate to the last grade of primary education (%) of Madagascar in 1998 to that in 2010?
Offer a very short reply. 0.97. What is the ratio of the Persistence rate to the last grade of primary education (%) in Slovenia in 1998 to that in 2010?
Provide a short and direct response. 1.01. What is the ratio of the Persistence rate to the last grade of primary education (%) in Heavily indebted poor countries in 1999 to that in 2001?
Provide a succinct answer. 0.89. What is the ratio of the Persistence rate to the last grade of primary education (%) of Lesotho in 1999 to that in 2001?
Offer a very short reply. 0.99. What is the ratio of the Persistence rate to the last grade of primary education (%) in Madagascar in 1999 to that in 2001?
Make the answer very short. 1.49. What is the ratio of the Persistence rate to the last grade of primary education (%) of Slovenia in 1999 to that in 2001?
Keep it short and to the point. 1.01. What is the ratio of the Persistence rate to the last grade of primary education (%) in Heavily indebted poor countries in 1999 to that in 2002?
Offer a very short reply. 0.92. What is the ratio of the Persistence rate to the last grade of primary education (%) of Lesotho in 1999 to that in 2002?
Provide a succinct answer. 0.87. What is the ratio of the Persistence rate to the last grade of primary education (%) of Madagascar in 1999 to that in 2002?
Make the answer very short. 0.95. What is the ratio of the Persistence rate to the last grade of primary education (%) of Slovenia in 1999 to that in 2002?
Provide a succinct answer. 1. What is the ratio of the Persistence rate to the last grade of primary education (%) of Heavily indebted poor countries in 1999 to that in 2008?
Give a very brief answer. 0.97. What is the ratio of the Persistence rate to the last grade of primary education (%) in Lesotho in 1999 to that in 2008?
Your response must be concise. 0.92. What is the ratio of the Persistence rate to the last grade of primary education (%) of Madagascar in 1999 to that in 2008?
Your answer should be very brief. 1.04. What is the ratio of the Persistence rate to the last grade of primary education (%) in Heavily indebted poor countries in 1999 to that in 2009?
Keep it short and to the point. 1.01. What is the ratio of the Persistence rate to the last grade of primary education (%) of Lesotho in 1999 to that in 2009?
Offer a terse response. 0.87. What is the ratio of the Persistence rate to the last grade of primary education (%) of Madagascar in 1999 to that in 2009?
Give a very brief answer. 1.49. What is the ratio of the Persistence rate to the last grade of primary education (%) in Slovenia in 1999 to that in 2009?
Offer a very short reply. 1.01. What is the ratio of the Persistence rate to the last grade of primary education (%) in Heavily indebted poor countries in 1999 to that in 2010?
Keep it short and to the point. 1.02. What is the ratio of the Persistence rate to the last grade of primary education (%) in Lesotho in 1999 to that in 2010?
Provide a succinct answer. 0.92. What is the ratio of the Persistence rate to the last grade of primary education (%) in Madagascar in 1999 to that in 2010?
Make the answer very short. 1.31. What is the ratio of the Persistence rate to the last grade of primary education (%) of Slovenia in 1999 to that in 2010?
Make the answer very short. 1.02. What is the ratio of the Persistence rate to the last grade of primary education (%) of Heavily indebted poor countries in 2001 to that in 2002?
Offer a very short reply. 1.03. What is the ratio of the Persistence rate to the last grade of primary education (%) of Lesotho in 2001 to that in 2002?
Give a very brief answer. 0.88. What is the ratio of the Persistence rate to the last grade of primary education (%) in Madagascar in 2001 to that in 2002?
Your answer should be very brief. 0.64. What is the ratio of the Persistence rate to the last grade of primary education (%) in Slovenia in 2001 to that in 2002?
Provide a succinct answer. 0.99. What is the ratio of the Persistence rate to the last grade of primary education (%) of Heavily indebted poor countries in 2001 to that in 2008?
Your answer should be very brief. 1.09. What is the ratio of the Persistence rate to the last grade of primary education (%) of Lesotho in 2001 to that in 2008?
Make the answer very short. 0.93. What is the ratio of the Persistence rate to the last grade of primary education (%) in Madagascar in 2001 to that in 2008?
Your answer should be very brief. 0.7. What is the ratio of the Persistence rate to the last grade of primary education (%) in Heavily indebted poor countries in 2001 to that in 2009?
Ensure brevity in your answer.  1.13. What is the ratio of the Persistence rate to the last grade of primary education (%) in Lesotho in 2001 to that in 2009?
Offer a very short reply. 0.88. What is the ratio of the Persistence rate to the last grade of primary education (%) in Madagascar in 2001 to that in 2009?
Ensure brevity in your answer.  1. What is the ratio of the Persistence rate to the last grade of primary education (%) in Heavily indebted poor countries in 2001 to that in 2010?
Ensure brevity in your answer.  1.15. What is the ratio of the Persistence rate to the last grade of primary education (%) in Lesotho in 2001 to that in 2010?
Offer a terse response. 0.93. What is the ratio of the Persistence rate to the last grade of primary education (%) in Madagascar in 2001 to that in 2010?
Offer a terse response. 0.88. What is the ratio of the Persistence rate to the last grade of primary education (%) of Heavily indebted poor countries in 2002 to that in 2008?
Make the answer very short. 1.05. What is the ratio of the Persistence rate to the last grade of primary education (%) in Lesotho in 2002 to that in 2008?
Your answer should be very brief. 1.06. What is the ratio of the Persistence rate to the last grade of primary education (%) of Madagascar in 2002 to that in 2008?
Keep it short and to the point. 1.1. What is the ratio of the Persistence rate to the last grade of primary education (%) in Slovenia in 2002 to that in 2008?
Offer a terse response. 1. What is the ratio of the Persistence rate to the last grade of primary education (%) of Heavily indebted poor countries in 2002 to that in 2009?
Your response must be concise. 1.1. What is the ratio of the Persistence rate to the last grade of primary education (%) of Lesotho in 2002 to that in 2009?
Offer a very short reply. 1. What is the ratio of the Persistence rate to the last grade of primary education (%) of Madagascar in 2002 to that in 2009?
Ensure brevity in your answer.  1.57. What is the ratio of the Persistence rate to the last grade of primary education (%) of Heavily indebted poor countries in 2002 to that in 2010?
Ensure brevity in your answer.  1.11. What is the ratio of the Persistence rate to the last grade of primary education (%) of Lesotho in 2002 to that in 2010?
Your answer should be very brief. 1.06. What is the ratio of the Persistence rate to the last grade of primary education (%) in Madagascar in 2002 to that in 2010?
Your answer should be very brief. 1.38. What is the ratio of the Persistence rate to the last grade of primary education (%) in Slovenia in 2002 to that in 2010?
Ensure brevity in your answer.  1.01. What is the ratio of the Persistence rate to the last grade of primary education (%) of Heavily indebted poor countries in 2008 to that in 2009?
Give a very brief answer. 1.04. What is the ratio of the Persistence rate to the last grade of primary education (%) of Lesotho in 2008 to that in 2009?
Ensure brevity in your answer.  0.95. What is the ratio of the Persistence rate to the last grade of primary education (%) of Madagascar in 2008 to that in 2009?
Make the answer very short. 1.42. What is the ratio of the Persistence rate to the last grade of primary education (%) of Slovenia in 2008 to that in 2009?
Offer a terse response. 1. What is the ratio of the Persistence rate to the last grade of primary education (%) of Heavily indebted poor countries in 2008 to that in 2010?
Provide a succinct answer. 1.05. What is the ratio of the Persistence rate to the last grade of primary education (%) of Madagascar in 2008 to that in 2010?
Give a very brief answer. 1.26. What is the ratio of the Persistence rate to the last grade of primary education (%) of Slovenia in 2008 to that in 2010?
Ensure brevity in your answer.  1.01. What is the ratio of the Persistence rate to the last grade of primary education (%) in Heavily indebted poor countries in 2009 to that in 2010?
Your answer should be compact. 1.01. What is the ratio of the Persistence rate to the last grade of primary education (%) in Lesotho in 2009 to that in 2010?
Give a very brief answer. 1.06. What is the ratio of the Persistence rate to the last grade of primary education (%) of Madagascar in 2009 to that in 2010?
Your answer should be very brief. 0.88. What is the ratio of the Persistence rate to the last grade of primary education (%) in Slovenia in 2009 to that in 2010?
Keep it short and to the point. 1.01. What is the difference between the highest and the second highest Persistence rate to the last grade of primary education (%) in Heavily indebted poor countries?
Make the answer very short. 1.97. What is the difference between the highest and the second highest Persistence rate to the last grade of primary education (%) of Lesotho?
Give a very brief answer. 0.02. What is the difference between the highest and the second highest Persistence rate to the last grade of primary education (%) of Madagascar?
Offer a terse response. 2.79. What is the difference between the highest and the second highest Persistence rate to the last grade of primary education (%) in Slovenia?
Provide a short and direct response. 0.28. What is the difference between the highest and the lowest Persistence rate to the last grade of primary education (%) in Heavily indebted poor countries?
Your answer should be compact. 10.38. What is the difference between the highest and the lowest Persistence rate to the last grade of primary education (%) in Lesotho?
Provide a short and direct response. 14.73. What is the difference between the highest and the lowest Persistence rate to the last grade of primary education (%) in Madagascar?
Your answer should be compact. 20.1. What is the difference between the highest and the lowest Persistence rate to the last grade of primary education (%) of Slovenia?
Your answer should be very brief. 1.53. 